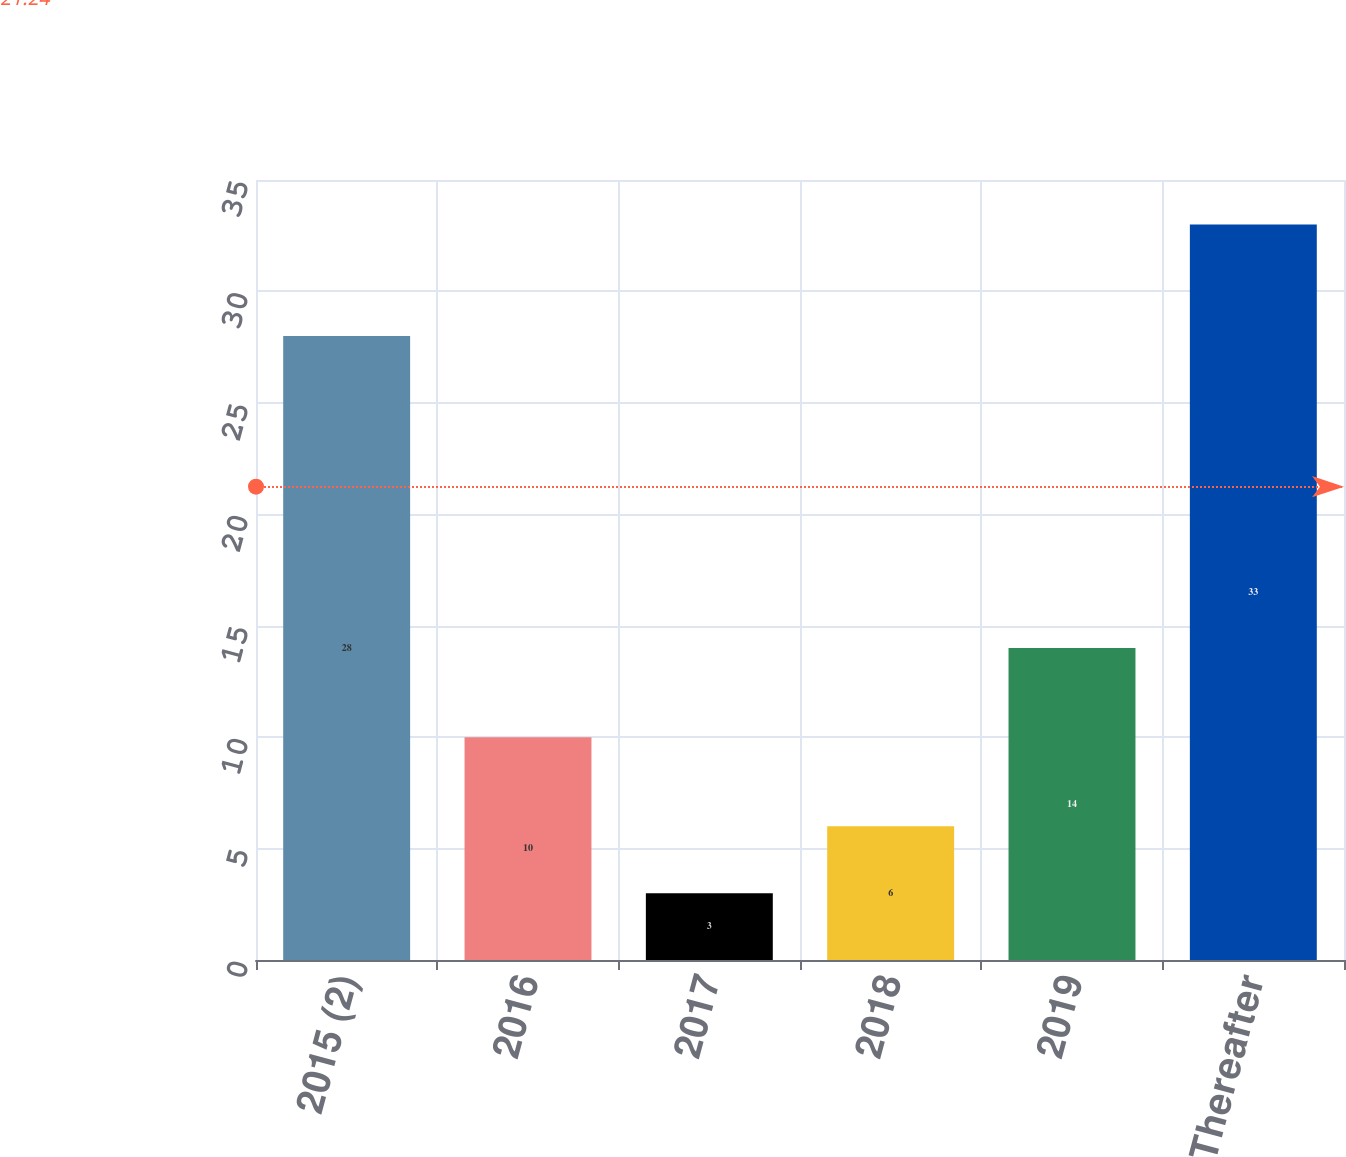Convert chart. <chart><loc_0><loc_0><loc_500><loc_500><bar_chart><fcel>2015 (2)<fcel>2016<fcel>2017<fcel>2018<fcel>2019<fcel>Thereafter<nl><fcel>28<fcel>10<fcel>3<fcel>6<fcel>14<fcel>33<nl></chart> 